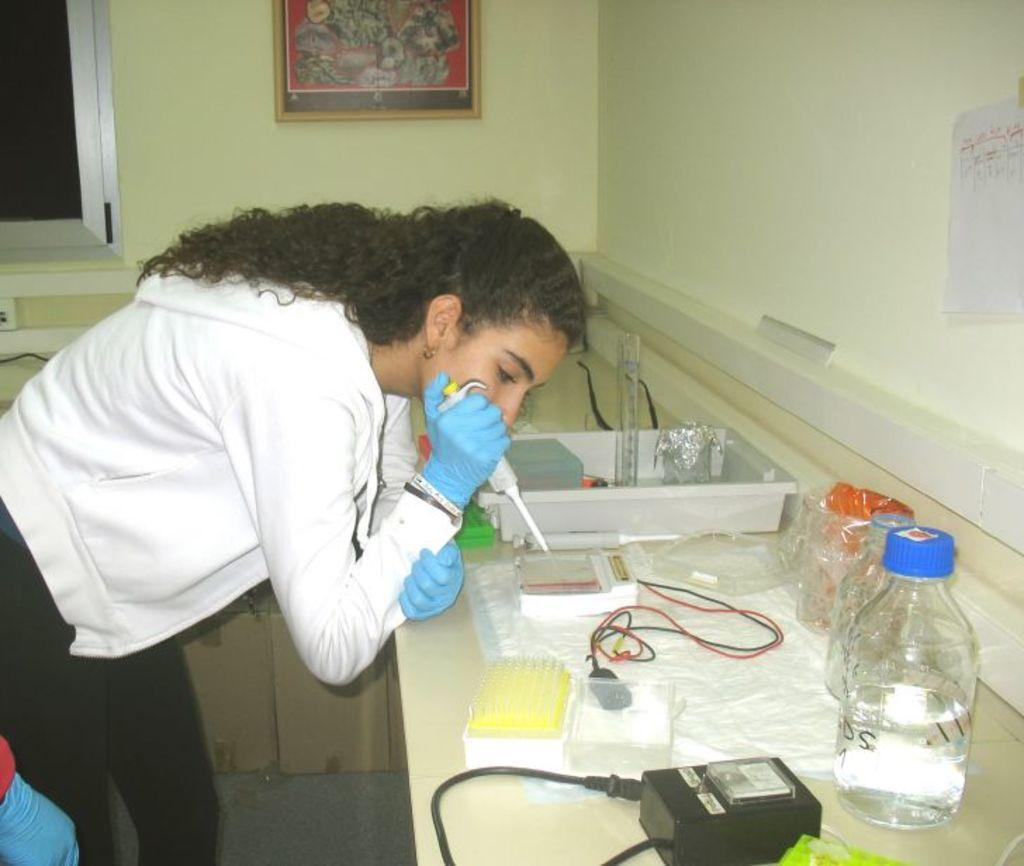What color is the wall in the image? The wall in the image is yellow. What can be seen hanging on the wall? There is a photo frame hanging on the wall. What is the woman in the image wearing? The woman is wearing a white color jacket. What piece of furniture is present in the image? There is a table in the image. What items are on the table? There are bottles and wires on the table. What is placed on the table along with the bottles and wires? There is a tray on the table. Who is the owner of the stage in the image? There is no stage present in the image. How does the woman in the image attract attention? The image does not provide information about how the woman attracts attention. 